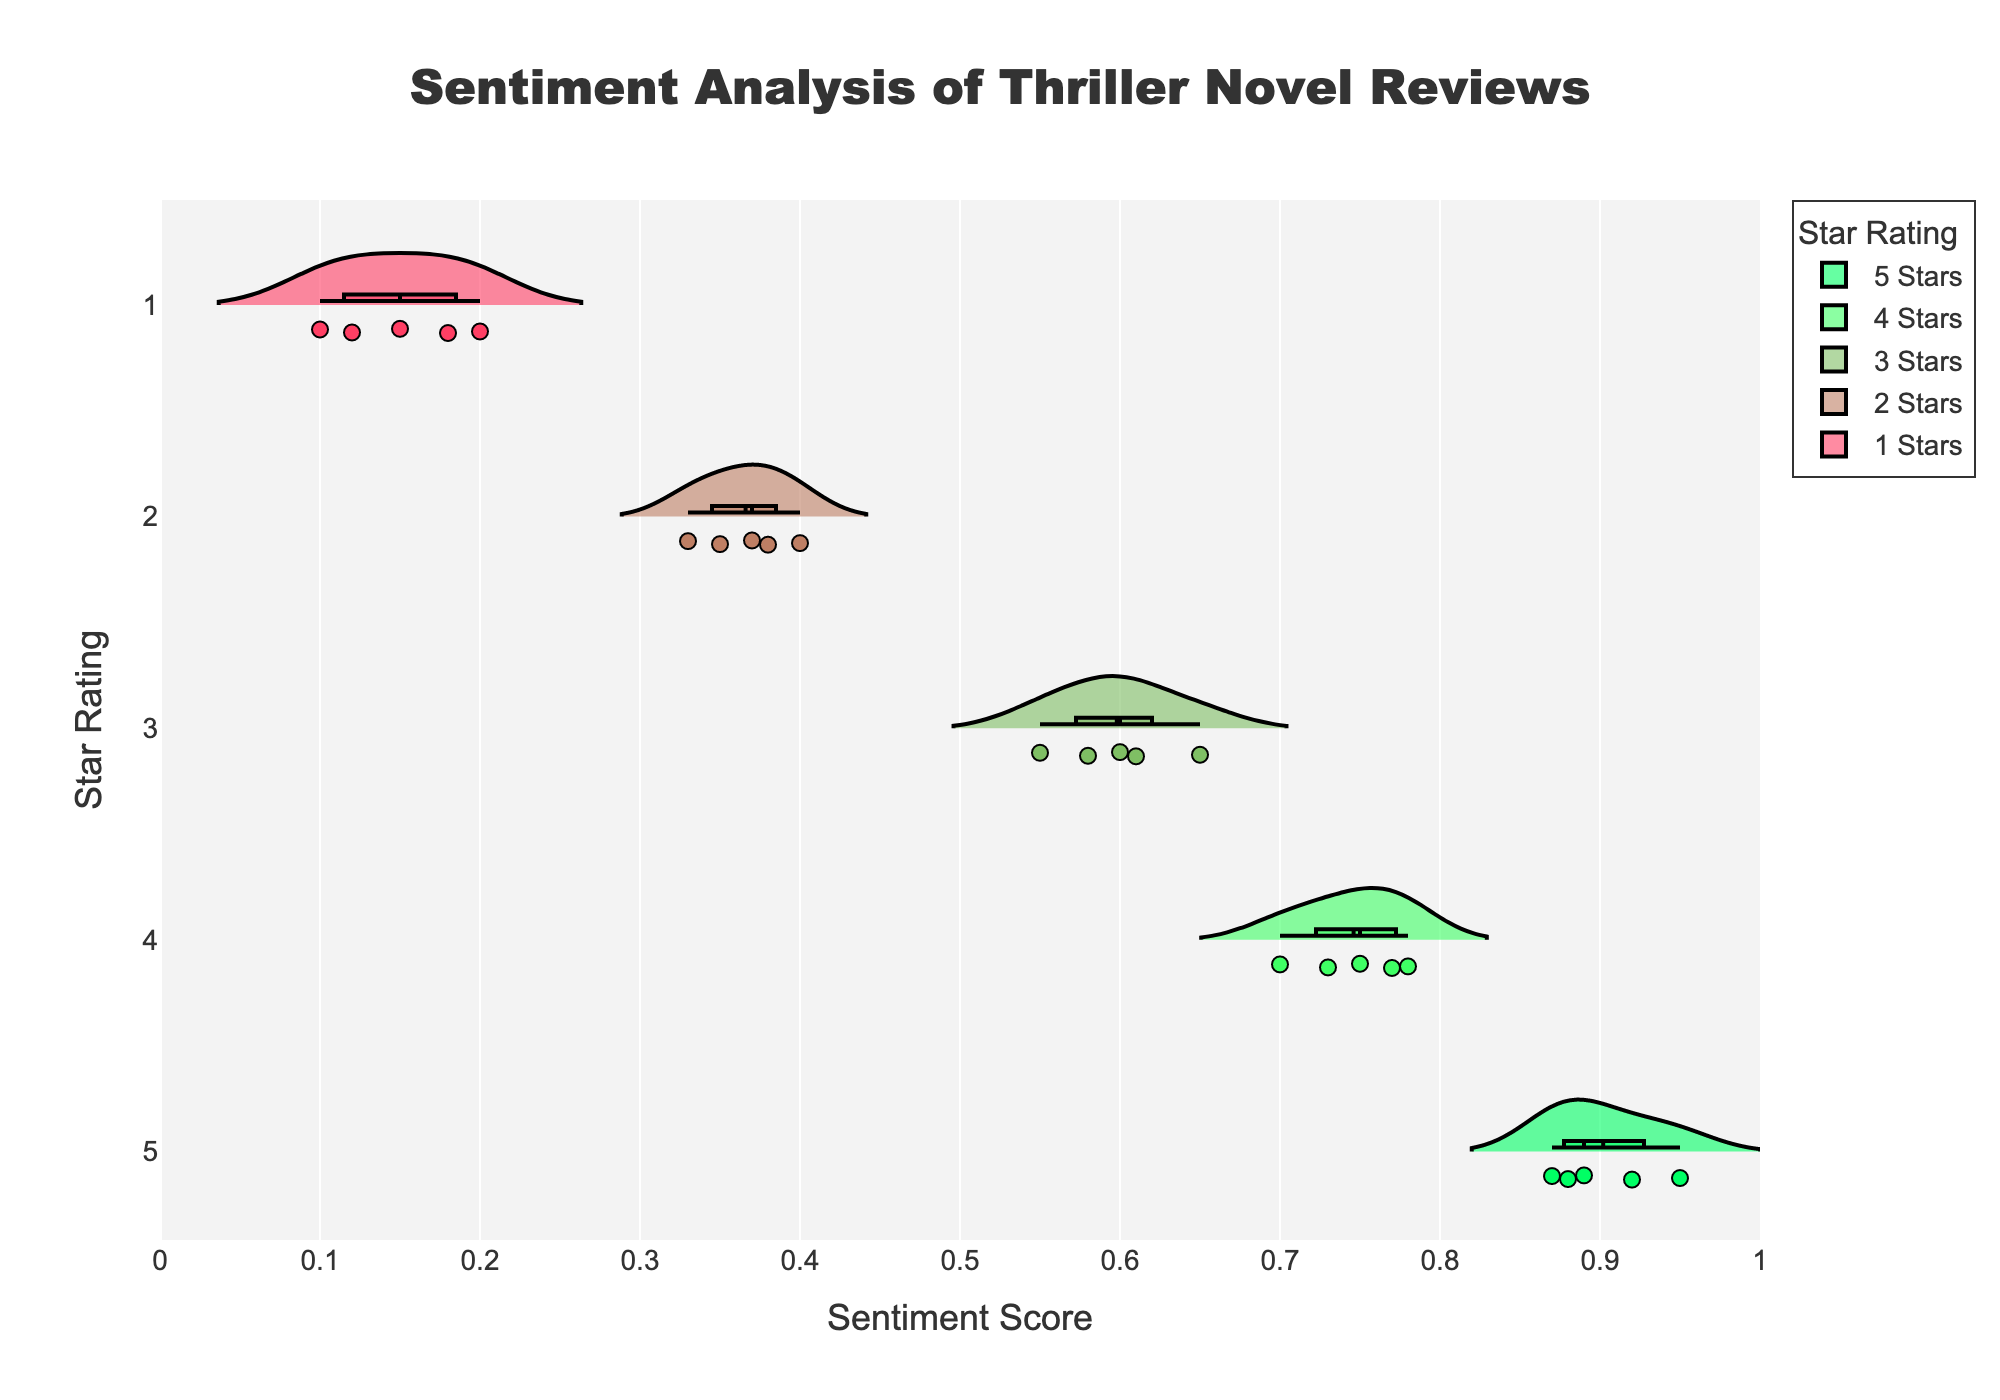What is the highest sentiment score shown for 5-star ratings? The plot displays different sentiment scores for each star rating in the form of horizontal violin plots. By examining the figure, the highest sentiment score for 5-star ratings reaches a point close to 1.0.
Answer: ~0.95 Which star rating has the median sentiment score closest to 0.50? A median line is typically displayed within a violin plot, which shows the middle value of the dataset. Among the star ratings, the 3-star rating's median line (solid, visible line) appears closest to 0.50.
Answer: 3-star How does the spread of sentiment scores for 1-star ratings compare to 4-star ratings? Comparing the shapes of the violin plots, the spread for 1-star ratings is narrower and more concentrated towards the lower sentiment scores, while the 4-star ratings have a broader spread and higher sentiment scores.
Answer: 1-star is narrower; 4-star is broader What is the approximate mean sentiment score for 2-star ratings? The mean sentiment score is typically marked by a dashed line within the violin plot. For 2-star ratings, the mean line is closer to 0.35.
Answer: ~0.35 Are the sentiment scores for 5-star reviews generally higher than those for 2-star reviews? By inspecting the positioning and spread of the violin plots, 5-star reviews show sentiment scores around 0.87-0.95, whereas 2-star reviews are around 0.33-0.40, indicating higher scores for 5-star reviews.
Answer: Yes Which star rating has the most tightly clustered sentiment scores? Observing the width and concentration of the violin plots, the 1-star ratings have a tightly clustered distribution of sentiment scores.
Answer: 1-star Between which star ratings is the difference in median sentiment scores the largest? Checking the positions of the median lines (solid lines) inside the violin plots, the difference between the 1-star and 5-star ratings appears to be the largest, spanning from around 0.10 to 0.90.
Answer: 1-star and 5-star Can we observe any outliers in the sentiment scores for 4-star ratings? Outliers are often shown as individual points outside the main spread of the violin plot. For 4-star ratings, there are no evident outliers as all points fall within the shape of the main distribution.
Answer: No How do the sentiment scores for "Gone Girl" compare across different star ratings? The violin plots show the distribution of sentiment scores for each star rating. By referring to individual points, the sentiment scores for "Gone Girl" vary from around 0.10 (1-star) to 0.95 (5-star).
Answer: Vary from 0.10 to 0.95 